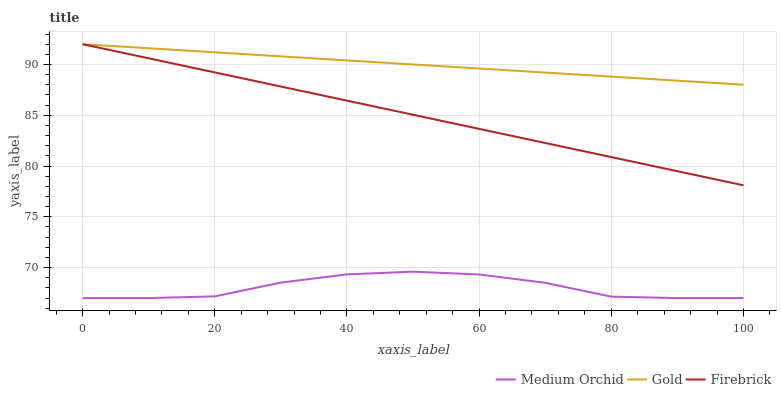Does Gold have the minimum area under the curve?
Answer yes or no. No. Does Medium Orchid have the maximum area under the curve?
Answer yes or no. No. Is Medium Orchid the smoothest?
Answer yes or no. No. Is Gold the roughest?
Answer yes or no. No. Does Gold have the lowest value?
Answer yes or no. No. Does Medium Orchid have the highest value?
Answer yes or no. No. Is Medium Orchid less than Gold?
Answer yes or no. Yes. Is Gold greater than Medium Orchid?
Answer yes or no. Yes. Does Medium Orchid intersect Gold?
Answer yes or no. No. 